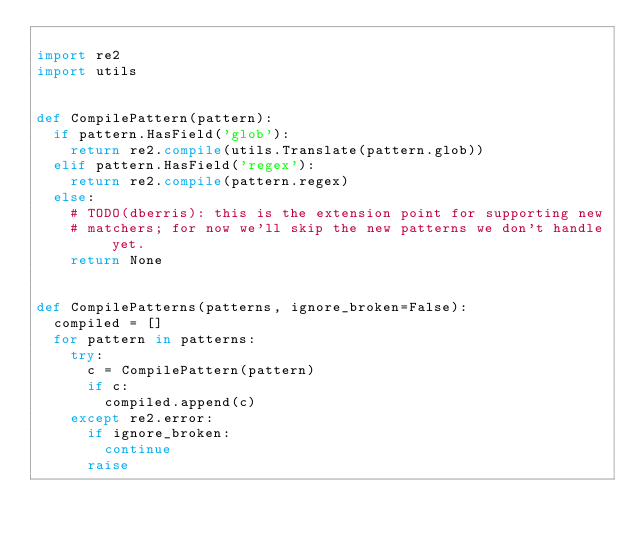<code> <loc_0><loc_0><loc_500><loc_500><_Python_>
import re2
import utils


def CompilePattern(pattern):
  if pattern.HasField('glob'):
    return re2.compile(utils.Translate(pattern.glob))
  elif pattern.HasField('regex'):
    return re2.compile(pattern.regex)
  else:
    # TODO(dberris): this is the extension point for supporting new
    # matchers; for now we'll skip the new patterns we don't handle yet.
    return None


def CompilePatterns(patterns, ignore_broken=False):
  compiled = []
  for pattern in patterns:
    try:
      c = CompilePattern(pattern)
      if c:
        compiled.append(c)
    except re2.error:
      if ignore_broken:
        continue
      raise</code> 